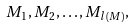Convert formula to latex. <formula><loc_0><loc_0><loc_500><loc_500>M _ { 1 } , M _ { 2 } , \dots , M _ { l ( M ) } ,</formula> 